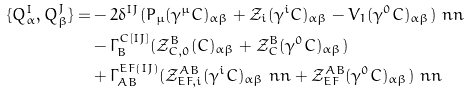Convert formula to latex. <formula><loc_0><loc_0><loc_500><loc_500>\{ Q _ { \alpha } ^ { I } , Q _ { \beta } ^ { J } \} = & - 2 \delta ^ { I J } ( P _ { \mu } ( \gamma ^ { \mu } C ) _ { \alpha \beta } + { \mathcal { Z } } _ { i } ( \gamma ^ { i } C ) _ { \alpha \beta } - V _ { 1 } ( \gamma ^ { 0 } C ) _ { \alpha \beta } ) \ n n \\ & - \Gamma ^ { C [ I J ] } _ { B } ( { \mathcal { Z } } ^ { B } _ { C , 0 } ( C ) _ { \alpha \beta } + { \mathcal { Z } } ^ { B } _ { C } ( \gamma ^ { 0 } C ) _ { \alpha \beta } ) \\ & + \Gamma ^ { E F ( I J ) } _ { A B } ( { \mathcal { Z } } ^ { A B } _ { E F , i } ( \gamma ^ { i } C ) _ { \alpha \beta } \ n n + { \mathcal { Z } } ^ { A B } _ { E F } ( \gamma ^ { 0 } C ) _ { \alpha \beta } ) \ n n</formula> 